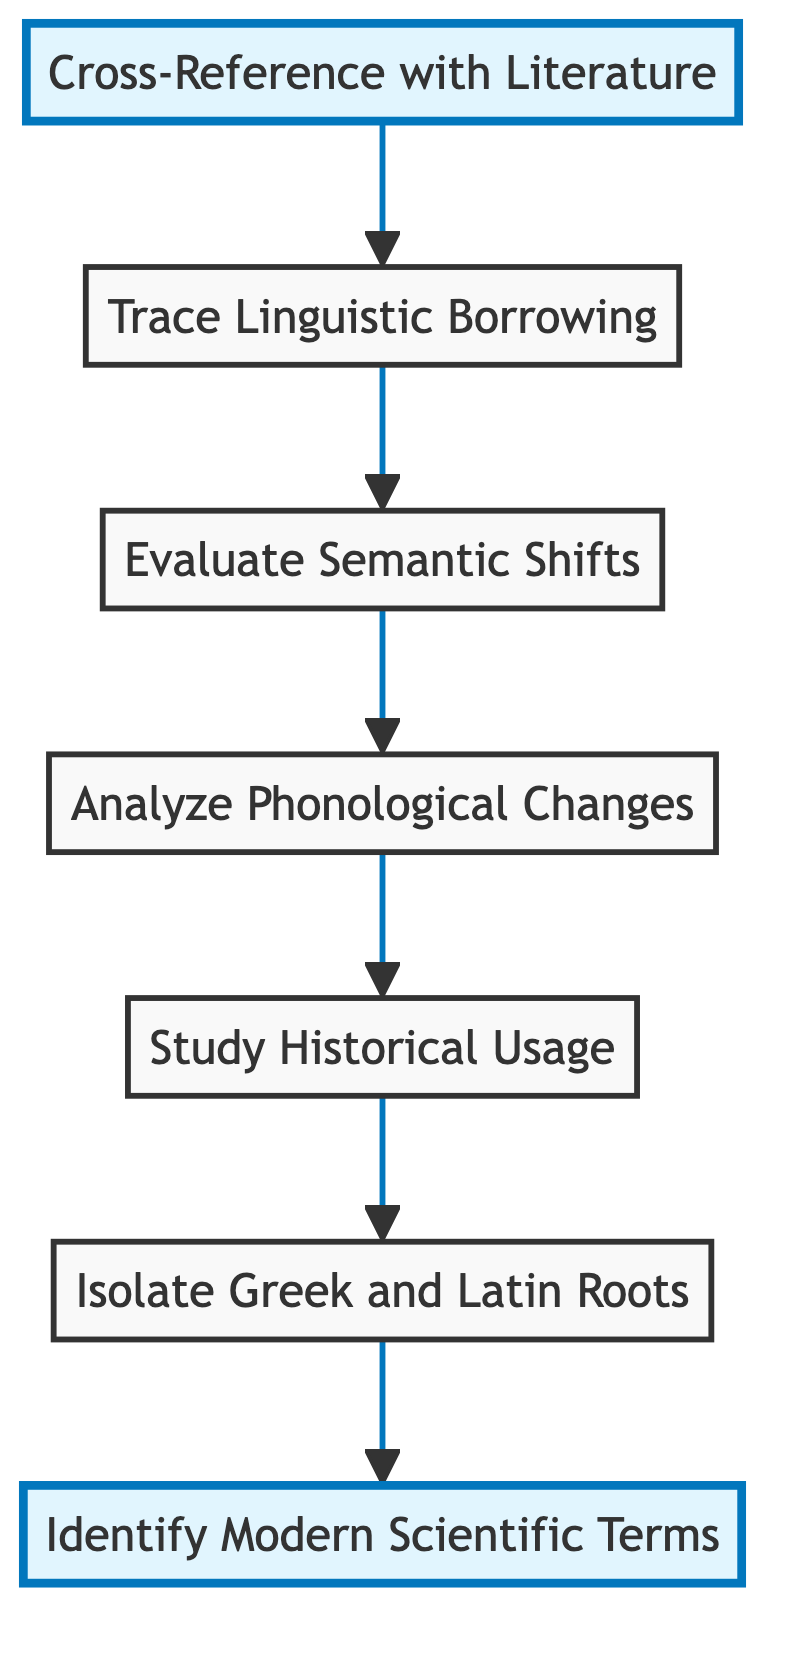What is the first step in the flow chart? The first step in the flow chart is represented at the bottom and is "Identify Modern Scientific Terms."
Answer: Identify Modern Scientific Terms How many nodes are present in the diagram? The diagram consists of seven nodes, which are the various steps listed from bottom to top.
Answer: 7 What is the last step in the flow chart? The last step in the flow chart, positioned at the top, is "Cross-Reference with Literature."
Answer: Cross-Reference with Literature Which step comes after isolating Greek and Latin roots? After "Isolate Greek and Latin Roots," the next step indicated in the flow chart is "Study Historical Usage."
Answer: Study Historical Usage How do "Analyze Phonological Changes" and "Evaluate Semantic Shifts" relate to each other? "Analyze Phonological Changes" comes after "Evaluate Semantic Shifts" in the flow; this indicates that evaluating semantic shifts precedes phonological changes in the flow of analysis.
Answer: Evaluate Semantic Shifts → Analyze Phonological Changes What is the relationship between "Trace Linguistic Borrowing" and "Cross-Reference with Literature"? "Trace Linguistic Borrowing" flows directly from "Cross-Reference with Literature," indicating that after cross-referencing, one would proceed to trace linguistic borrowing.
Answer: Cross-Reference with Literature → Trace Linguistic Borrowing Which step immediately follows "Study Historical Usage"? The step that immediately follows "Study Historical Usage" is "Analyze Phonological Changes."
Answer: Analyze Phonological Changes 